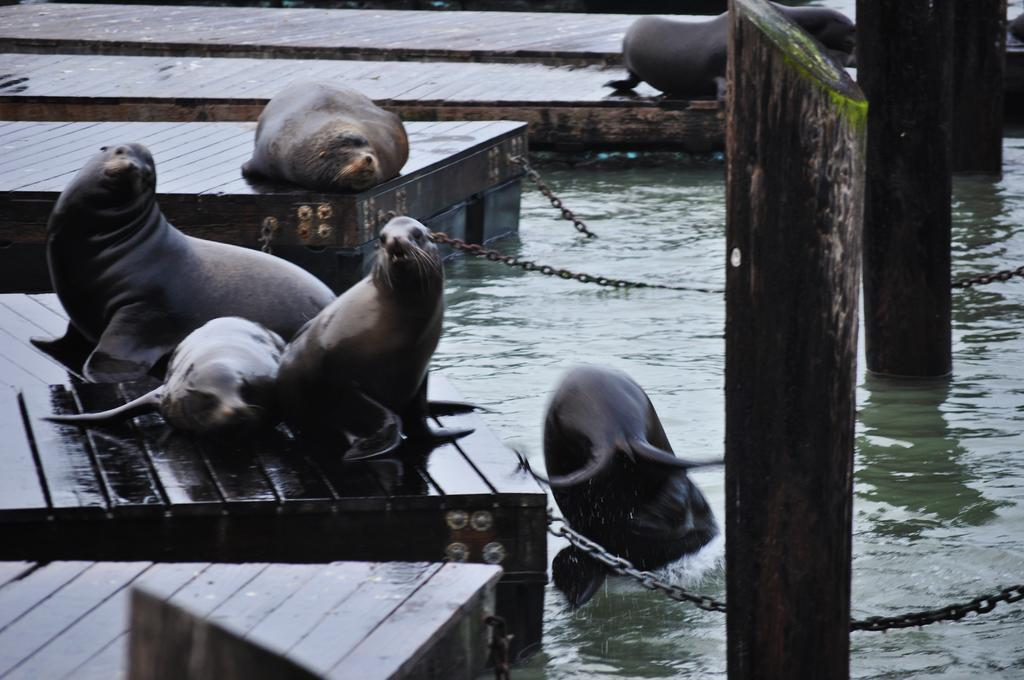What type of animals can be seen in the image? There are seals in the image. What is the primary element in which the seals are situated? There is water visible in the image, and the seals are in the water. What structures can be seen in the image? There are wooden poles and stands in the image. What type of school can be seen in the image? There is no school present in the image; it features seals in water with wooden poles and stands. What color is the skirt worn by the seals in the image? Seals do not wear skirts, and there are no skirts present in the image. 